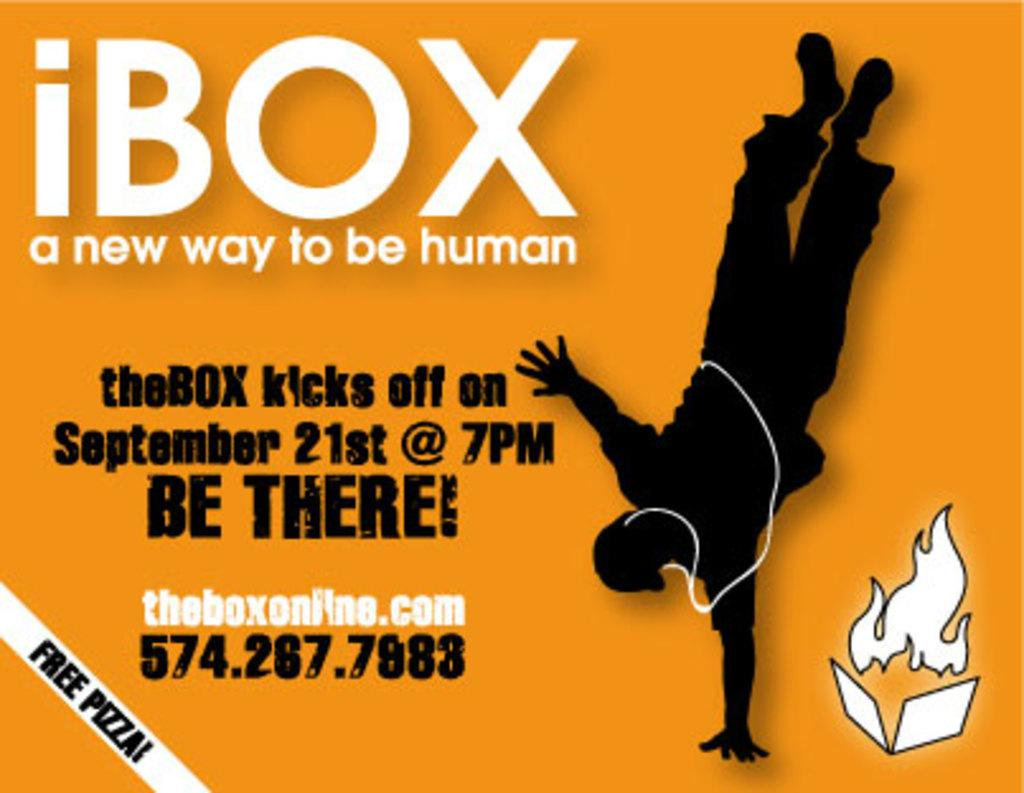<image>
Share a concise interpretation of the image provided. A poster has a breakdancer on it advertising a show on September 21st. 